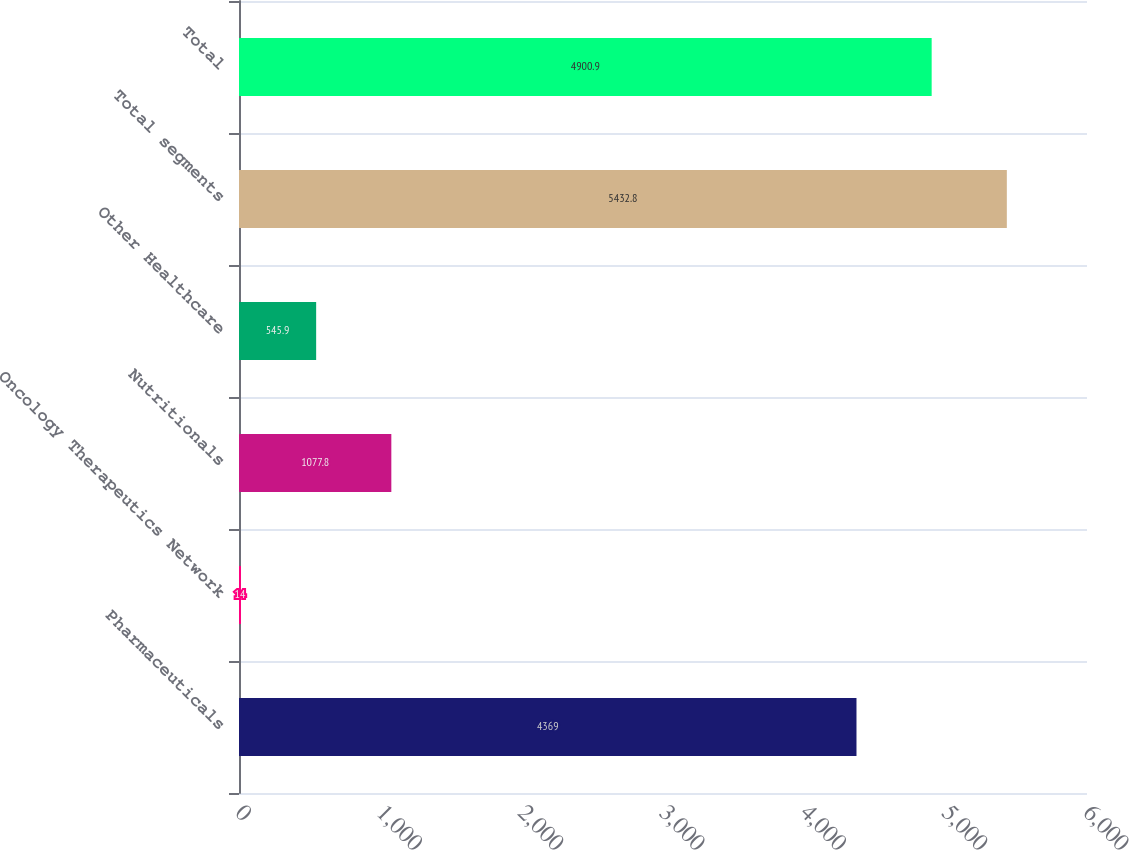Convert chart. <chart><loc_0><loc_0><loc_500><loc_500><bar_chart><fcel>Pharmaceuticals<fcel>Oncology Therapeutics Network<fcel>Nutritionals<fcel>Other Healthcare<fcel>Total segments<fcel>Total<nl><fcel>4369<fcel>14<fcel>1077.8<fcel>545.9<fcel>5432.8<fcel>4900.9<nl></chart> 